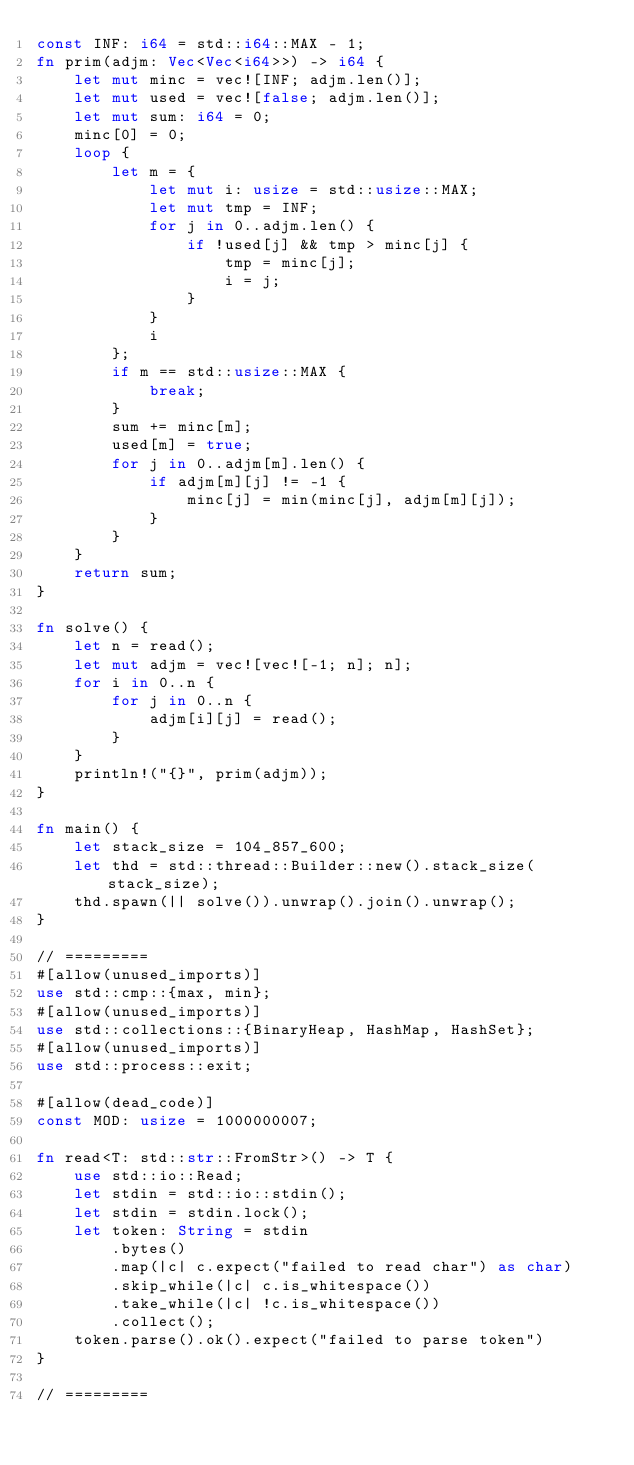<code> <loc_0><loc_0><loc_500><loc_500><_Rust_>const INF: i64 = std::i64::MAX - 1;
fn prim(adjm: Vec<Vec<i64>>) -> i64 {
    let mut minc = vec![INF; adjm.len()];
    let mut used = vec![false; adjm.len()];
    let mut sum: i64 = 0;
    minc[0] = 0;
    loop {
        let m = {
            let mut i: usize = std::usize::MAX;
            let mut tmp = INF;
            for j in 0..adjm.len() {
                if !used[j] && tmp > minc[j] {
                    tmp = minc[j];
                    i = j;
                }
            }
            i
        };
        if m == std::usize::MAX {
            break;
        }
        sum += minc[m];
        used[m] = true;
        for j in 0..adjm[m].len() {
            if adjm[m][j] != -1 {
                minc[j] = min(minc[j], adjm[m][j]);
            }
        }
    }
    return sum;
}

fn solve() {
    let n = read();
    let mut adjm = vec![vec![-1; n]; n];
    for i in 0..n {
        for j in 0..n {
            adjm[i][j] = read();
        }
    }
    println!("{}", prim(adjm));
}

fn main() {
    let stack_size = 104_857_600;
    let thd = std::thread::Builder::new().stack_size(stack_size);
    thd.spawn(|| solve()).unwrap().join().unwrap();
}

// =========
#[allow(unused_imports)]
use std::cmp::{max, min};
#[allow(unused_imports)]
use std::collections::{BinaryHeap, HashMap, HashSet};
#[allow(unused_imports)]
use std::process::exit;

#[allow(dead_code)]
const MOD: usize = 1000000007;

fn read<T: std::str::FromStr>() -> T {
    use std::io::Read;
    let stdin = std::io::stdin();
    let stdin = stdin.lock();
    let token: String = stdin
        .bytes()
        .map(|c| c.expect("failed to read char") as char)
        .skip_while(|c| c.is_whitespace())
        .take_while(|c| !c.is_whitespace())
        .collect();
    token.parse().ok().expect("failed to parse token")
}

// =========

</code> 